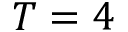<formula> <loc_0><loc_0><loc_500><loc_500>T = 4</formula> 